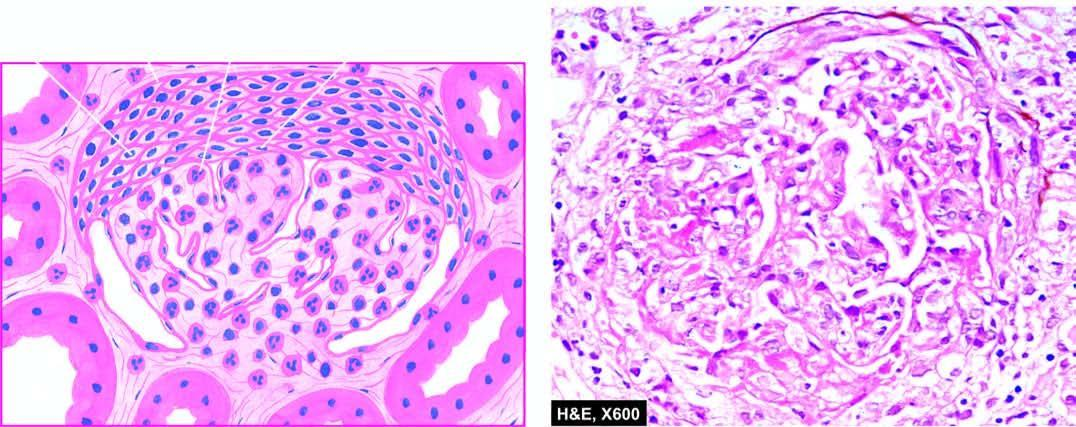what are crescents in bowman 's space forming?
Answer the question using a single word or phrase. Adhesions between the glomerular tuft and bowman 's capsule 